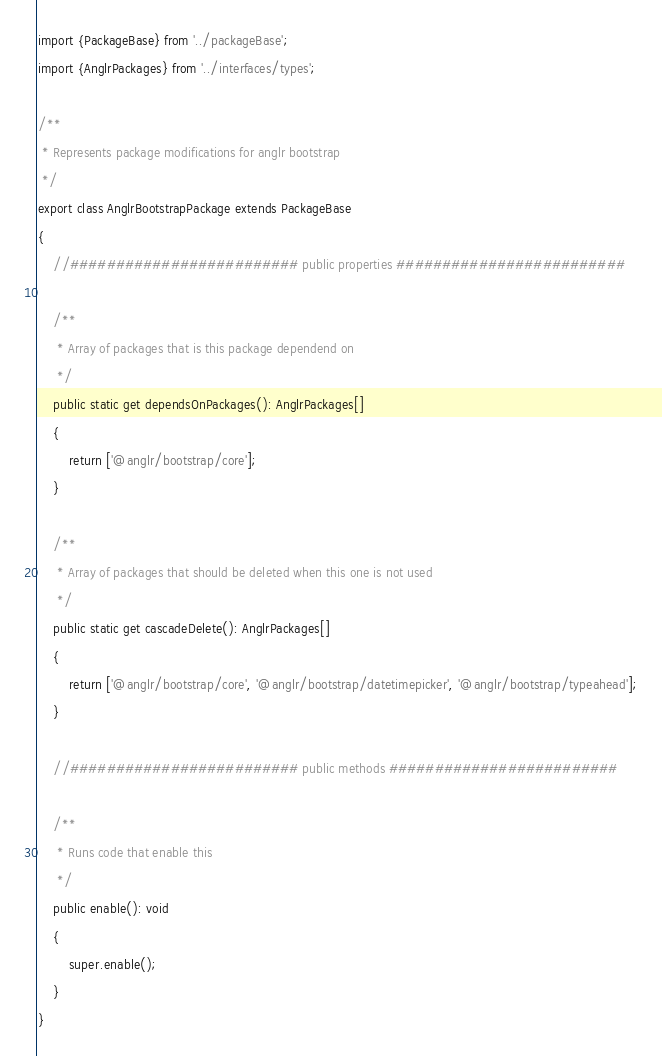Convert code to text. <code><loc_0><loc_0><loc_500><loc_500><_TypeScript_>import {PackageBase} from '../packageBase';
import {AnglrPackages} from '../interfaces/types';

/**
 * Represents package modifications for anglr bootstrap
 */
export class AnglrBootstrapPackage extends PackageBase
{
    //######################### public properties #########################

    /**
     * Array of packages that is this package dependend on
     */
    public static get dependsOnPackages(): AnglrPackages[]
    {
        return ['@anglr/bootstrap/core'];
    }

    /**
     * Array of packages that should be deleted when this one is not used
     */
    public static get cascadeDelete(): AnglrPackages[]
    {
        return ['@anglr/bootstrap/core', '@anglr/bootstrap/datetimepicker', '@anglr/bootstrap/typeahead'];
    }

    //######################### public methods #########################

    /**
     * Runs code that enable this
     */
    public enable(): void
    {
        super.enable();
    }
}</code> 